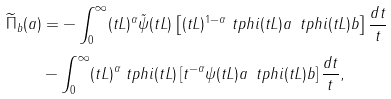<formula> <loc_0><loc_0><loc_500><loc_500>\widetilde { \Pi } _ { b } ( a ) & = - \int _ { 0 } ^ { \infty } ( t L ) ^ { \alpha } \tilde { \psi } ( t L ) \left [ ( t L ) ^ { 1 - \alpha } \ t p h i ( t L ) a \, \ t p h i ( t L ) b \right ] \frac { d t } { t } \\ & - \int _ { 0 } ^ { \infty } ( t L ) ^ { \alpha } \ t p h i ( t L ) \left [ t ^ { - \alpha } \psi ( t L ) a \, \ t p h i ( t L ) b \right ] \frac { d t } { t } ,</formula> 